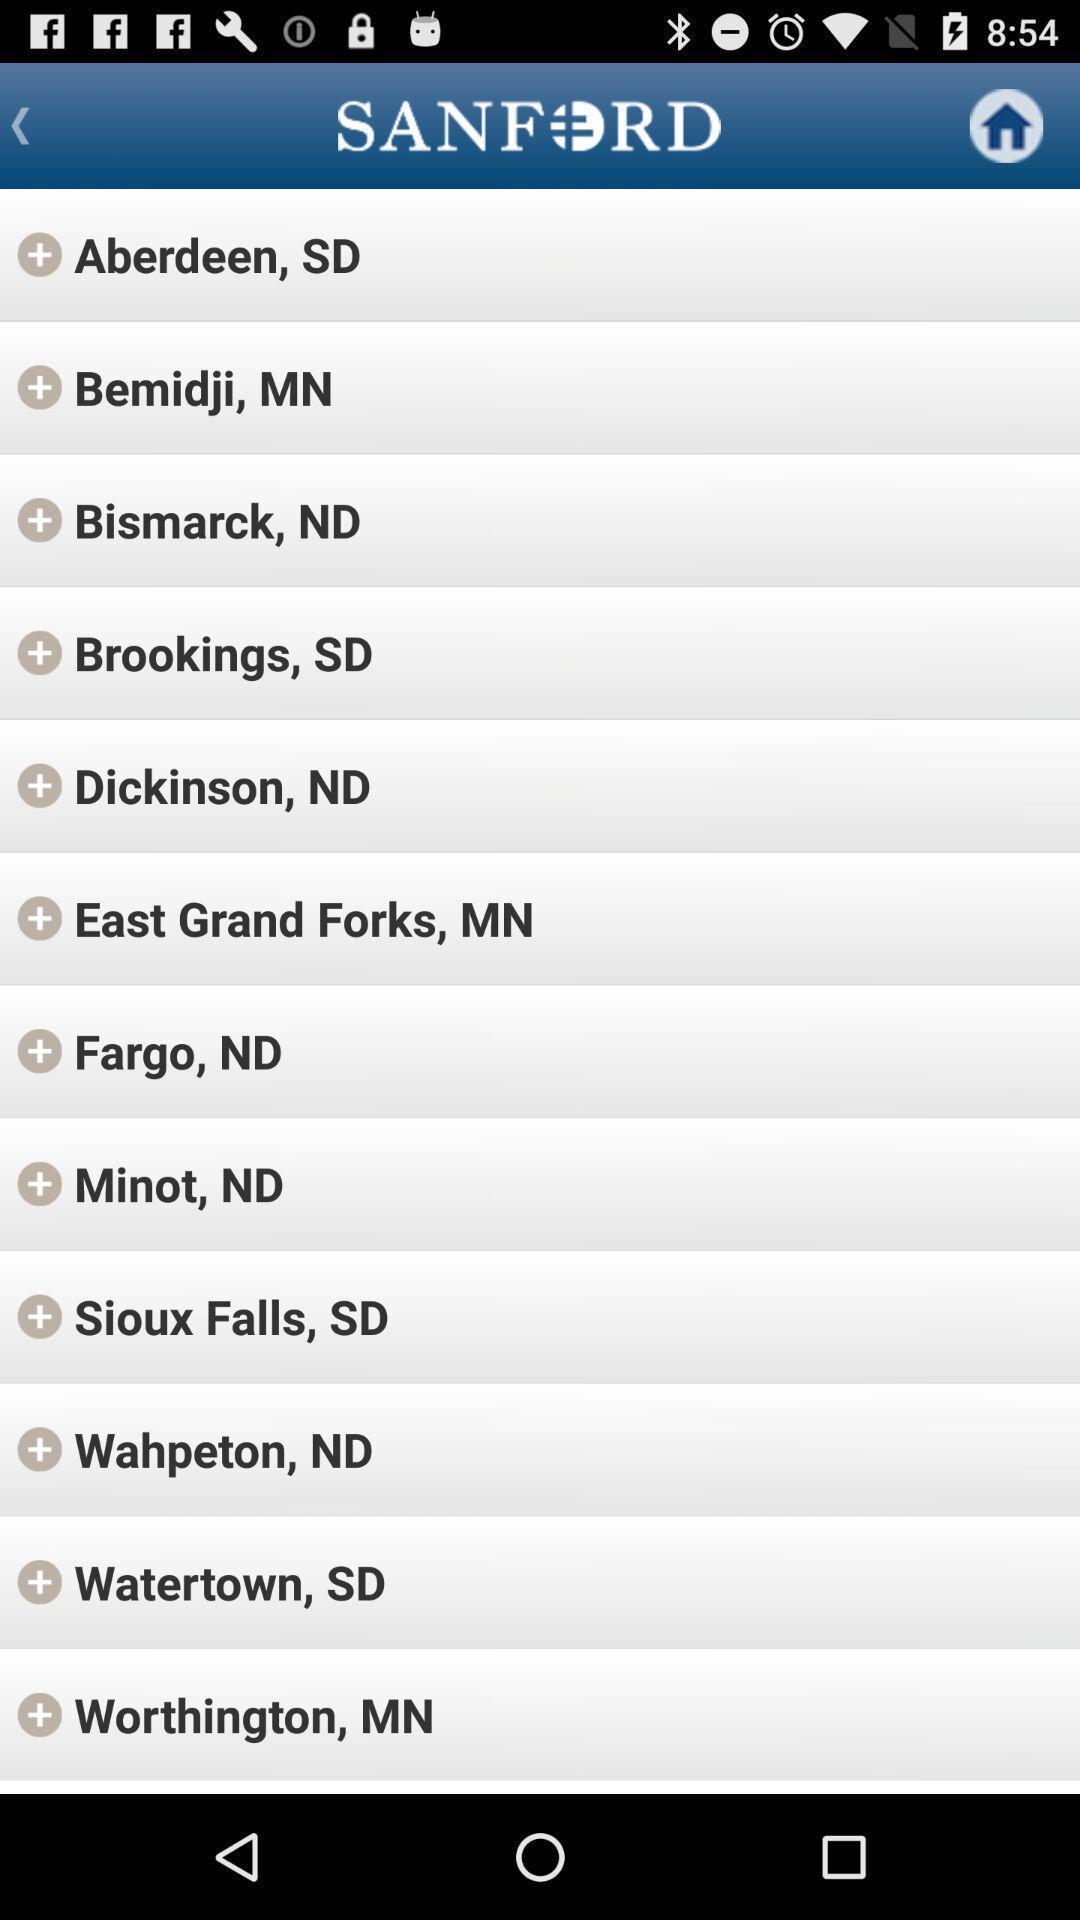What is the overall content of this screenshot? Page is showing cities of different countries. 